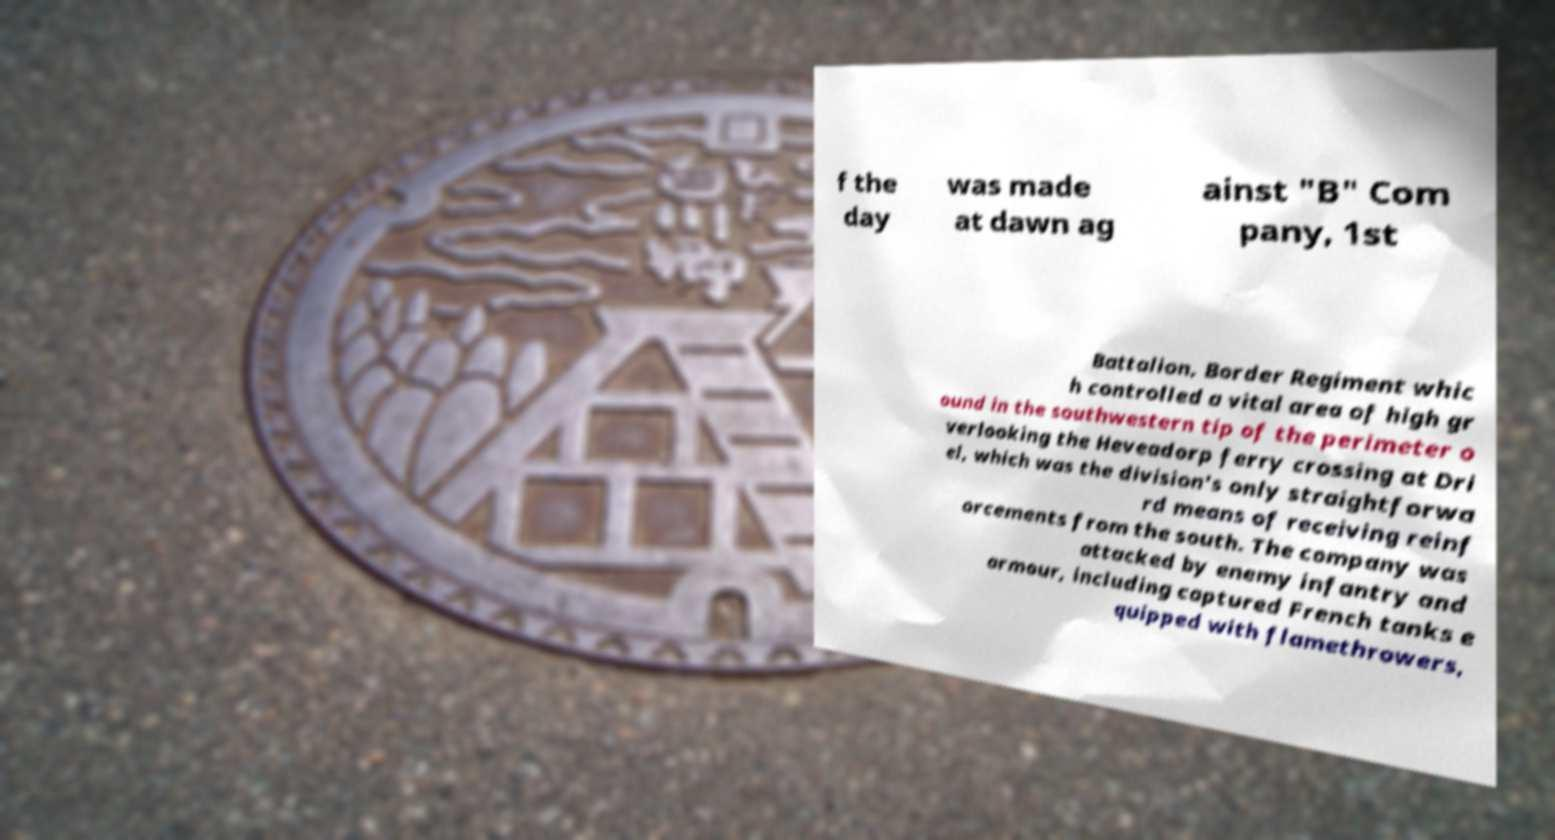For documentation purposes, I need the text within this image transcribed. Could you provide that? f the day was made at dawn ag ainst "B" Com pany, 1st Battalion, Border Regiment whic h controlled a vital area of high gr ound in the southwestern tip of the perimeter o verlooking the Heveadorp ferry crossing at Dri el, which was the division's only straightforwa rd means of receiving reinf orcements from the south. The company was attacked by enemy infantry and armour, including captured French tanks e quipped with flamethrowers, 